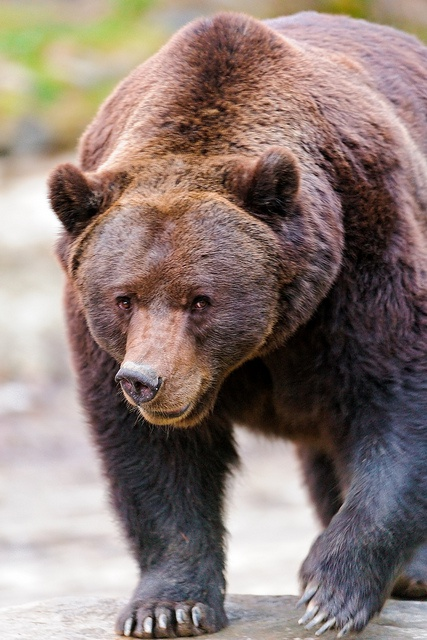Describe the objects in this image and their specific colors. I can see a bear in tan, black, gray, and pink tones in this image. 